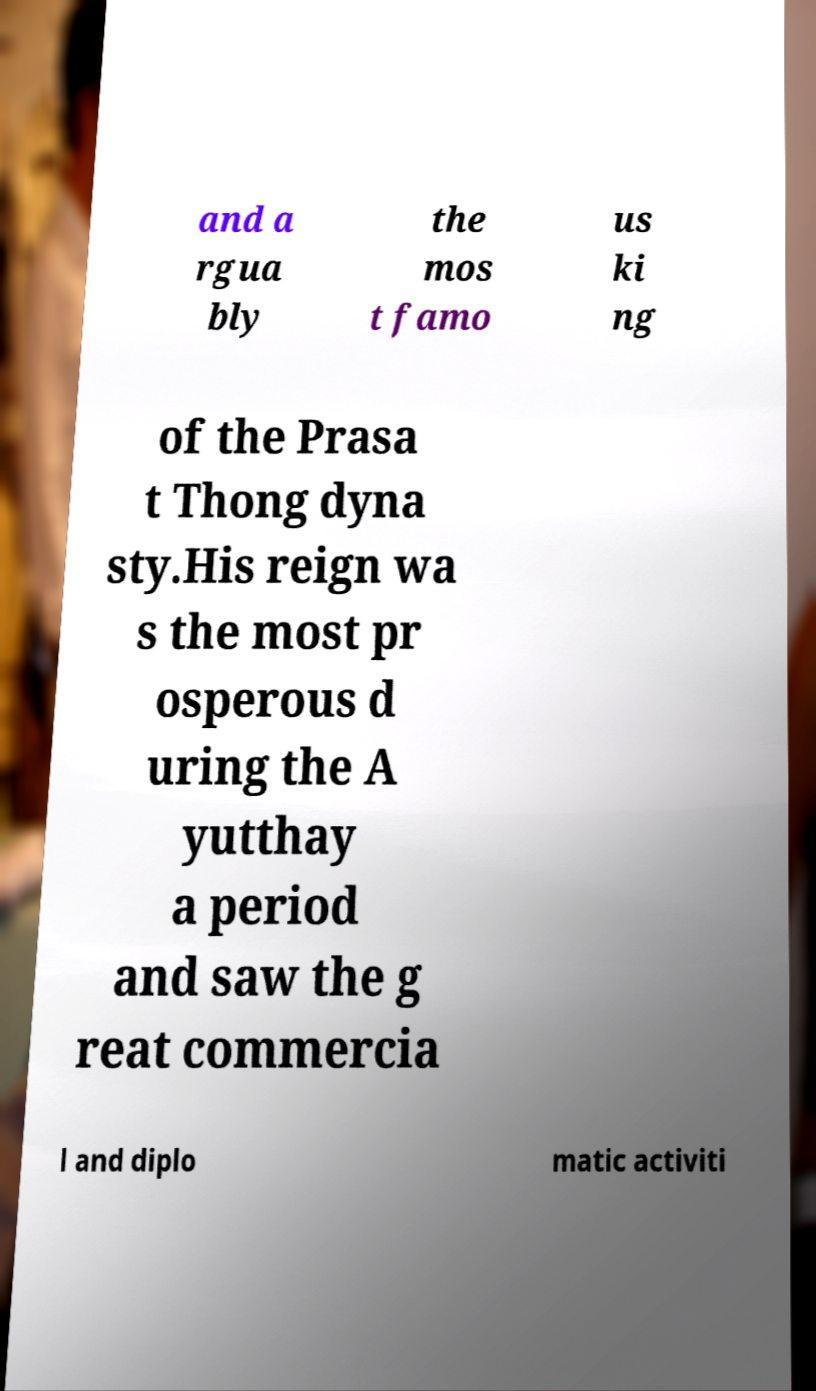For documentation purposes, I need the text within this image transcribed. Could you provide that? and a rgua bly the mos t famo us ki ng of the Prasa t Thong dyna sty.His reign wa s the most pr osperous d uring the A yutthay a period and saw the g reat commercia l and diplo matic activiti 